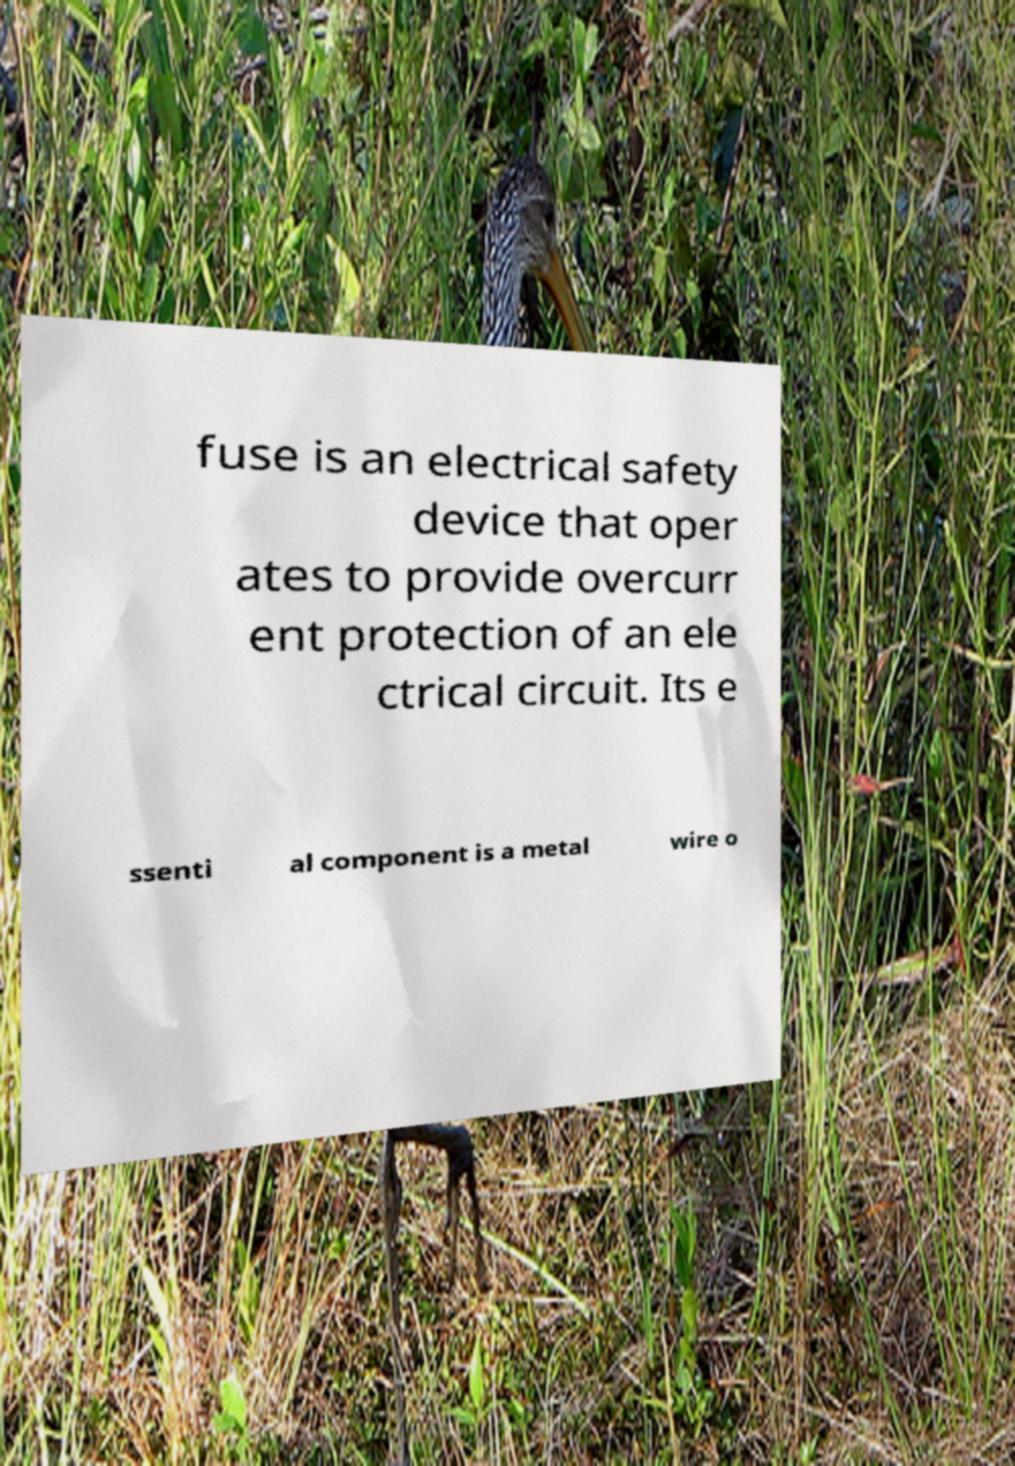I need the written content from this picture converted into text. Can you do that? fuse is an electrical safety device that oper ates to provide overcurr ent protection of an ele ctrical circuit. Its e ssenti al component is a metal wire o 